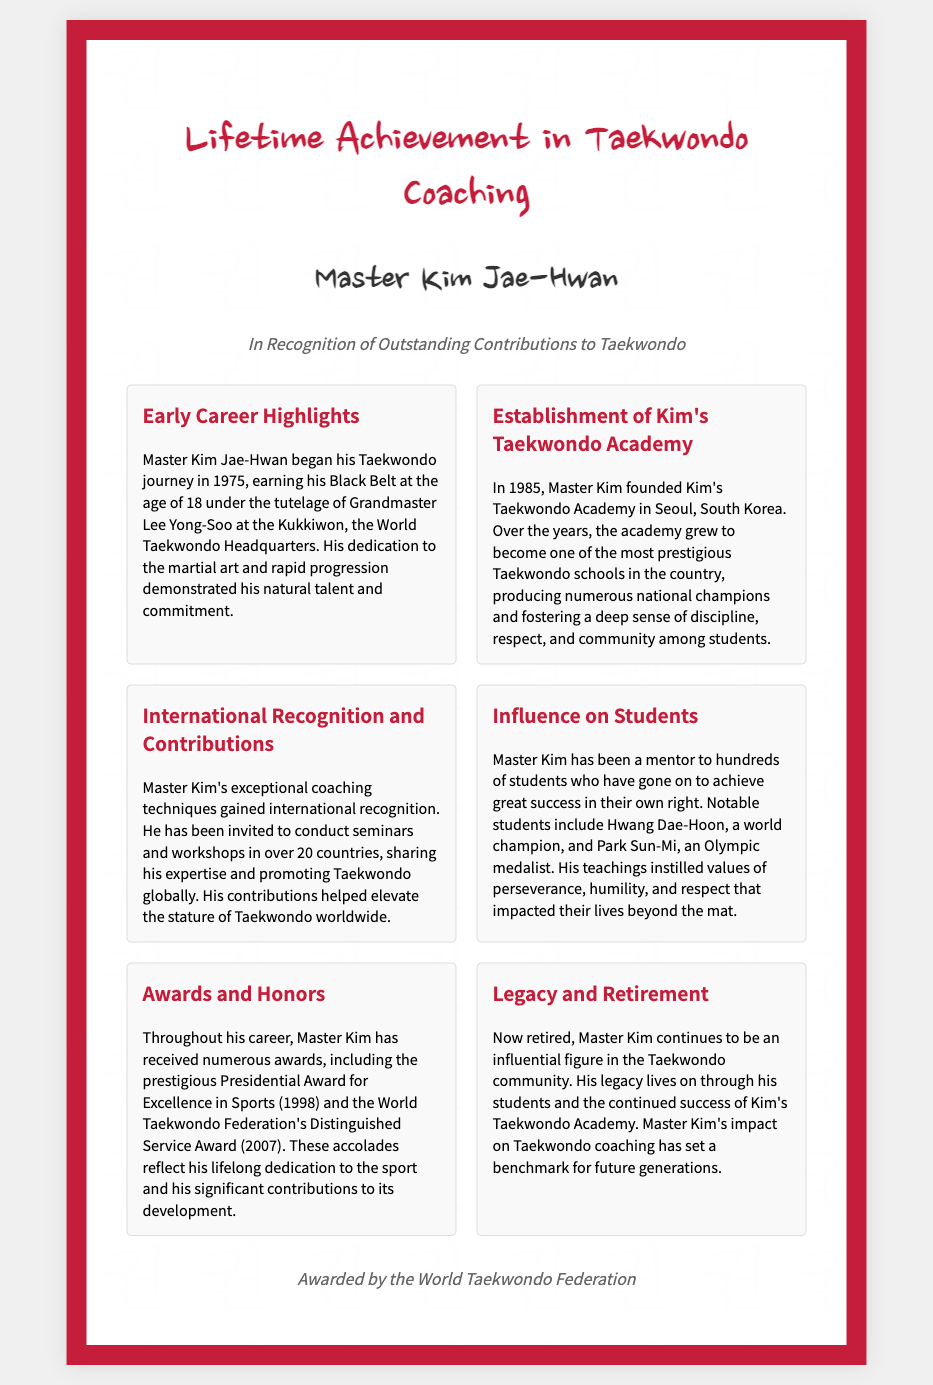What year did Master Kim begin his Taekwondo journey? The document states that Master Kim began his Taekwondo journey in 1975.
Answer: 1975 Who was Master Kim's instructor for his Black Belt? The document mentions that Master Kim earned his Black Belt under Grandmaster Lee Yong-Soo.
Answer: Grandmaster Lee Yong-Soo In what year was Kim's Taekwondo Academy founded? According to the document, Kim's Taekwondo Academy was established in 1985.
Answer: 1985 What prestigious award did Master Kim receive in 1998? The document lists that Master Kim received the Presidential Award for Excellence in Sports in 1998.
Answer: Presidential Award for Excellence in Sports How many countries has Master Kim conducted seminars in? The document states that Master Kim conducted seminars and workshops in over 20 countries.
Answer: Over 20 Which notable student of Master Kim is a world champion? The document mentions Hwang Dae-Hoon as a notable student who is a world champion.
Answer: Hwang Dae-Hoon What values did Master Kim instill in his students? The document specifies that Master Kim instilled values of perseverance, humility, and respect in his students.
Answer: Perseverance, humility, and respect What is one of the significant impacts of Master Kim’s coaching on students? The document explains that Master Kim's teachings impacted his students' lives beyond the mat.
Answer: Impacted their lives beyond the mat What is the name of Master Kim's Taekwondo Academy? The document indicates that the academy is named Kim's Taekwondo Academy.
Answer: Kim's Taekwondo Academy 